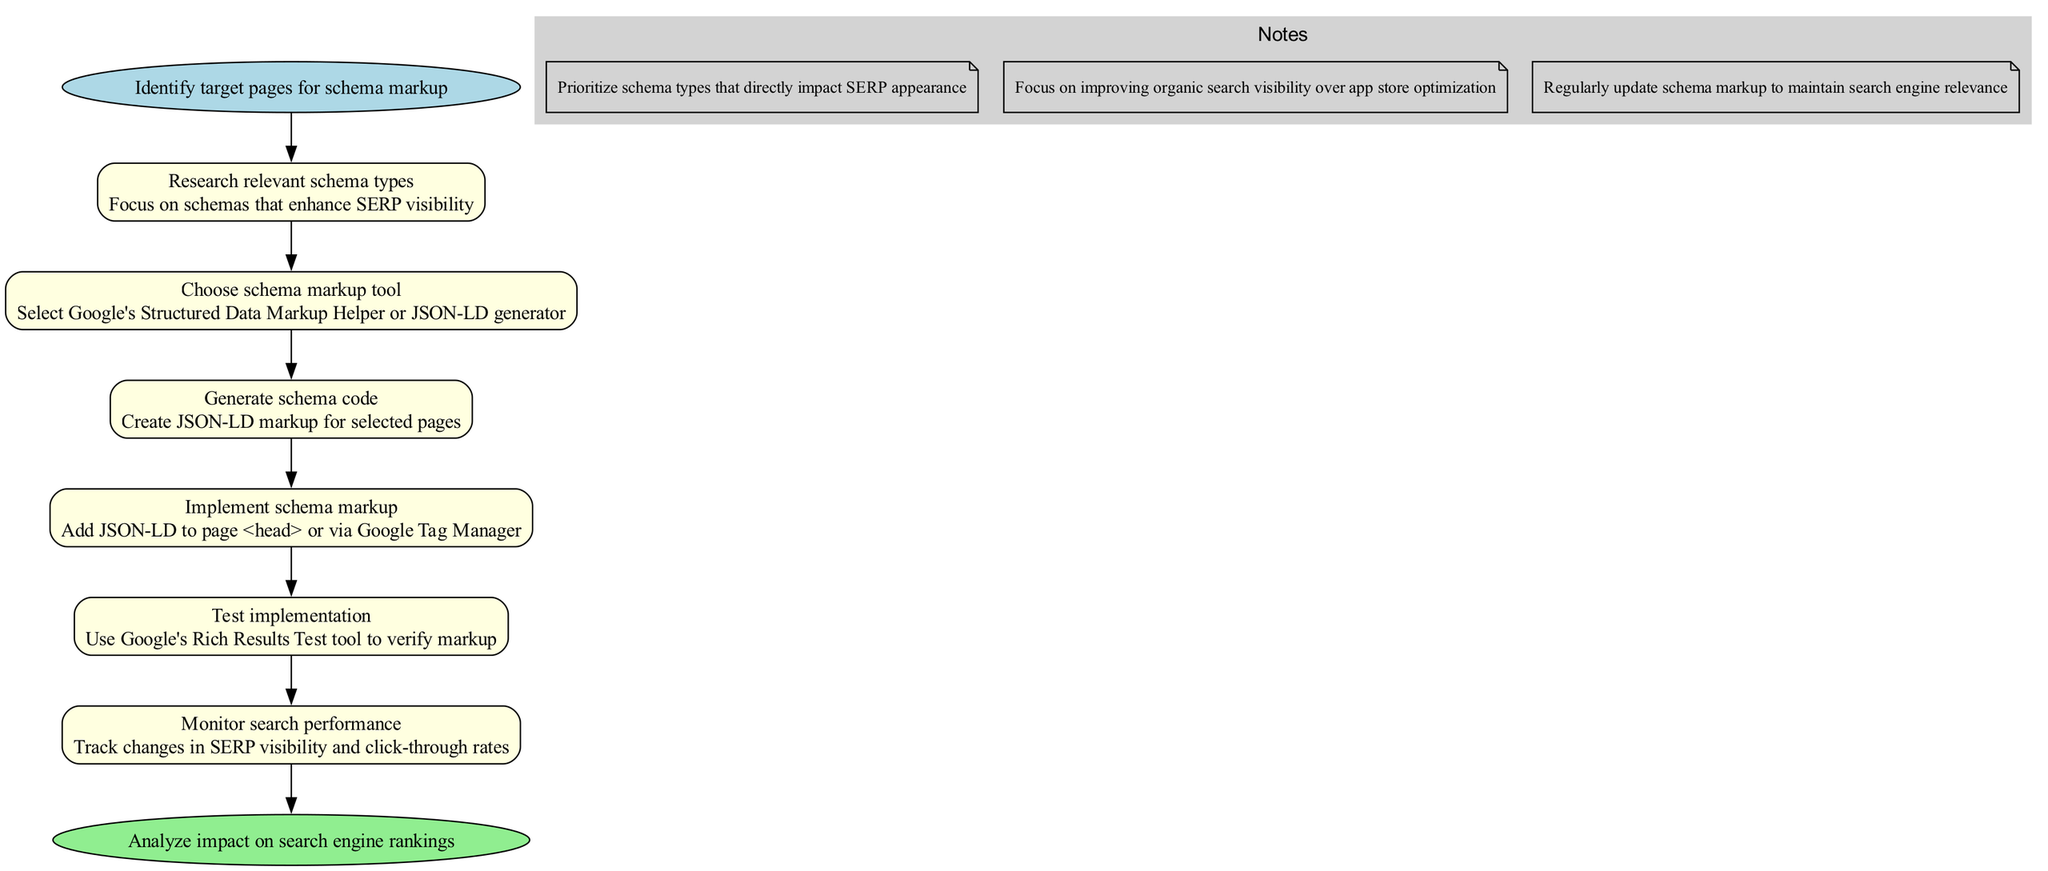What is the first step in the process? The first step is labeled as "Identify target pages for schema markup". It is indicated as the starting point in the diagram, where the pathway begins.
Answer: Identify target pages for schema markup How many steps are there in total? There are 6 steps listed in the diagram between the start and end nodes. After counting all the steps in the listed process, the total is confirmed to be 6.
Answer: 6 What is the last step before analyzing the impact? The last step before reaching the endpoint is "Monitor search performance". This step is positioned just before the final analysis, as shown by its placement in the diagram.
Answer: Monitor search performance Which tool should be chosen for schema markup? The diagram specifies "Google's Structured Data Markup Helper or JSON-LD generator" as the tools to choose from. It is a clear instruction indicated in the corresponding step.
Answer: Google's Structured Data Markup Helper or JSON-LD generator What is one of the important notes related to the implementation? One of the important notes states, "Focus on improving organic search visibility over app store optimization". This is mentioned as part of the supplementary information in the diagram.
Answer: Focus on improving organic search visibility over app store optimization After generating schema code, what is the next step? After "Generate schema code", the next step listed is "Implement schema markup". This is directly indicated as the next action to take in the process flow.
Answer: Implement schema markup Which testing tool is recommended in the process? The recommended testing tool is "Google's Rich Results Test tool". It is specifically mentioned within the diagram as part of the testing step.
Answer: Google's Rich Results Test tool What color represents the steps in the diagram? The steps are represented with a light yellow color in the diagram. This consistent coloring is used for all the steps to visually delineate them from the start and end nodes.
Answer: Light yellow 